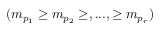Convert formula to latex. <formula><loc_0><loc_0><loc_500><loc_500>( m _ { p _ { 1 } } \geq m _ { p _ { 2 } } \geq , \dots , \geq m _ { p _ { r } } )</formula> 